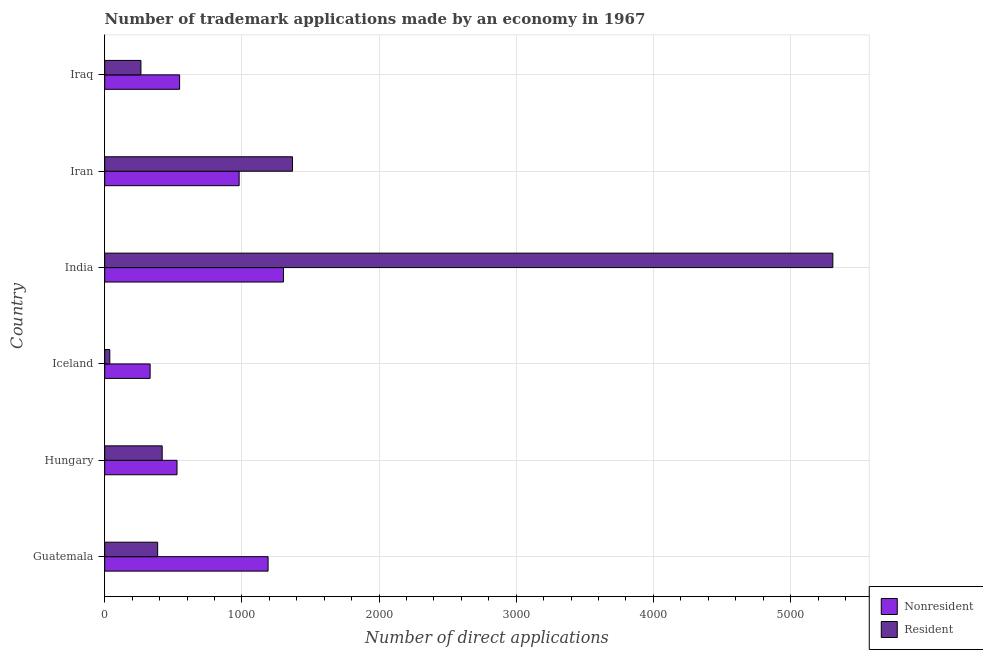How many different coloured bars are there?
Ensure brevity in your answer.  2. How many bars are there on the 3rd tick from the top?
Ensure brevity in your answer.  2. What is the label of the 6th group of bars from the top?
Offer a terse response. Guatemala. In how many cases, is the number of bars for a given country not equal to the number of legend labels?
Make the answer very short. 0. What is the number of trademark applications made by non residents in Iran?
Your answer should be very brief. 980. Across all countries, what is the maximum number of trademark applications made by non residents?
Ensure brevity in your answer.  1303. Across all countries, what is the minimum number of trademark applications made by non residents?
Make the answer very short. 331. In which country was the number of trademark applications made by residents maximum?
Provide a succinct answer. India. In which country was the number of trademark applications made by non residents minimum?
Give a very brief answer. Iceland. What is the total number of trademark applications made by residents in the graph?
Offer a terse response. 7783. What is the difference between the number of trademark applications made by non residents in Guatemala and that in Iraq?
Offer a very short reply. 645. What is the difference between the number of trademark applications made by residents in Guatemala and the number of trademark applications made by non residents in India?
Your answer should be compact. -917. What is the average number of trademark applications made by residents per country?
Provide a short and direct response. 1297.17. What is the difference between the number of trademark applications made by residents and number of trademark applications made by non residents in Hungary?
Provide a short and direct response. -108. In how many countries, is the number of trademark applications made by non residents greater than 1200 ?
Offer a terse response. 1. What is the ratio of the number of trademark applications made by non residents in Hungary to that in Iceland?
Keep it short and to the point. 1.59. Is the number of trademark applications made by non residents in Iceland less than that in Iran?
Provide a succinct answer. Yes. What is the difference between the highest and the second highest number of trademark applications made by non residents?
Offer a terse response. 112. What is the difference between the highest and the lowest number of trademark applications made by non residents?
Provide a succinct answer. 972. What does the 1st bar from the top in India represents?
Give a very brief answer. Resident. What does the 1st bar from the bottom in India represents?
Offer a very short reply. Nonresident. How many bars are there?
Provide a short and direct response. 12. What is the difference between two consecutive major ticks on the X-axis?
Your answer should be compact. 1000. Where does the legend appear in the graph?
Offer a terse response. Bottom right. What is the title of the graph?
Your response must be concise. Number of trademark applications made by an economy in 1967. What is the label or title of the X-axis?
Your answer should be compact. Number of direct applications. What is the label or title of the Y-axis?
Ensure brevity in your answer.  Country. What is the Number of direct applications in Nonresident in Guatemala?
Your answer should be very brief. 1191. What is the Number of direct applications of Resident in Guatemala?
Your answer should be compact. 386. What is the Number of direct applications of Nonresident in Hungary?
Give a very brief answer. 527. What is the Number of direct applications of Resident in Hungary?
Provide a short and direct response. 419. What is the Number of direct applications of Nonresident in Iceland?
Give a very brief answer. 331. What is the Number of direct applications in Resident in Iceland?
Ensure brevity in your answer.  37. What is the Number of direct applications of Nonresident in India?
Provide a succinct answer. 1303. What is the Number of direct applications in Resident in India?
Make the answer very short. 5308. What is the Number of direct applications of Nonresident in Iran?
Provide a short and direct response. 980. What is the Number of direct applications in Resident in Iran?
Give a very brief answer. 1369. What is the Number of direct applications of Nonresident in Iraq?
Offer a very short reply. 546. What is the Number of direct applications in Resident in Iraq?
Give a very brief answer. 264. Across all countries, what is the maximum Number of direct applications in Nonresident?
Give a very brief answer. 1303. Across all countries, what is the maximum Number of direct applications in Resident?
Provide a short and direct response. 5308. Across all countries, what is the minimum Number of direct applications in Nonresident?
Offer a very short reply. 331. What is the total Number of direct applications of Nonresident in the graph?
Give a very brief answer. 4878. What is the total Number of direct applications of Resident in the graph?
Your answer should be very brief. 7783. What is the difference between the Number of direct applications of Nonresident in Guatemala and that in Hungary?
Provide a short and direct response. 664. What is the difference between the Number of direct applications in Resident in Guatemala and that in Hungary?
Offer a very short reply. -33. What is the difference between the Number of direct applications of Nonresident in Guatemala and that in Iceland?
Keep it short and to the point. 860. What is the difference between the Number of direct applications in Resident in Guatemala and that in Iceland?
Give a very brief answer. 349. What is the difference between the Number of direct applications in Nonresident in Guatemala and that in India?
Offer a very short reply. -112. What is the difference between the Number of direct applications of Resident in Guatemala and that in India?
Ensure brevity in your answer.  -4922. What is the difference between the Number of direct applications of Nonresident in Guatemala and that in Iran?
Offer a very short reply. 211. What is the difference between the Number of direct applications in Resident in Guatemala and that in Iran?
Give a very brief answer. -983. What is the difference between the Number of direct applications in Nonresident in Guatemala and that in Iraq?
Keep it short and to the point. 645. What is the difference between the Number of direct applications in Resident in Guatemala and that in Iraq?
Your answer should be very brief. 122. What is the difference between the Number of direct applications in Nonresident in Hungary and that in Iceland?
Offer a terse response. 196. What is the difference between the Number of direct applications of Resident in Hungary and that in Iceland?
Offer a terse response. 382. What is the difference between the Number of direct applications in Nonresident in Hungary and that in India?
Provide a succinct answer. -776. What is the difference between the Number of direct applications in Resident in Hungary and that in India?
Provide a short and direct response. -4889. What is the difference between the Number of direct applications of Nonresident in Hungary and that in Iran?
Your answer should be very brief. -453. What is the difference between the Number of direct applications in Resident in Hungary and that in Iran?
Your answer should be very brief. -950. What is the difference between the Number of direct applications of Nonresident in Hungary and that in Iraq?
Offer a terse response. -19. What is the difference between the Number of direct applications of Resident in Hungary and that in Iraq?
Give a very brief answer. 155. What is the difference between the Number of direct applications in Nonresident in Iceland and that in India?
Ensure brevity in your answer.  -972. What is the difference between the Number of direct applications in Resident in Iceland and that in India?
Ensure brevity in your answer.  -5271. What is the difference between the Number of direct applications of Nonresident in Iceland and that in Iran?
Give a very brief answer. -649. What is the difference between the Number of direct applications in Resident in Iceland and that in Iran?
Your answer should be compact. -1332. What is the difference between the Number of direct applications in Nonresident in Iceland and that in Iraq?
Your response must be concise. -215. What is the difference between the Number of direct applications of Resident in Iceland and that in Iraq?
Your answer should be compact. -227. What is the difference between the Number of direct applications of Nonresident in India and that in Iran?
Provide a succinct answer. 323. What is the difference between the Number of direct applications of Resident in India and that in Iran?
Offer a terse response. 3939. What is the difference between the Number of direct applications of Nonresident in India and that in Iraq?
Make the answer very short. 757. What is the difference between the Number of direct applications of Resident in India and that in Iraq?
Offer a terse response. 5044. What is the difference between the Number of direct applications of Nonresident in Iran and that in Iraq?
Keep it short and to the point. 434. What is the difference between the Number of direct applications of Resident in Iran and that in Iraq?
Your answer should be very brief. 1105. What is the difference between the Number of direct applications in Nonresident in Guatemala and the Number of direct applications in Resident in Hungary?
Ensure brevity in your answer.  772. What is the difference between the Number of direct applications of Nonresident in Guatemala and the Number of direct applications of Resident in Iceland?
Your answer should be compact. 1154. What is the difference between the Number of direct applications of Nonresident in Guatemala and the Number of direct applications of Resident in India?
Keep it short and to the point. -4117. What is the difference between the Number of direct applications in Nonresident in Guatemala and the Number of direct applications in Resident in Iran?
Your response must be concise. -178. What is the difference between the Number of direct applications of Nonresident in Guatemala and the Number of direct applications of Resident in Iraq?
Offer a terse response. 927. What is the difference between the Number of direct applications of Nonresident in Hungary and the Number of direct applications of Resident in Iceland?
Your response must be concise. 490. What is the difference between the Number of direct applications in Nonresident in Hungary and the Number of direct applications in Resident in India?
Offer a terse response. -4781. What is the difference between the Number of direct applications of Nonresident in Hungary and the Number of direct applications of Resident in Iran?
Ensure brevity in your answer.  -842. What is the difference between the Number of direct applications in Nonresident in Hungary and the Number of direct applications in Resident in Iraq?
Offer a terse response. 263. What is the difference between the Number of direct applications in Nonresident in Iceland and the Number of direct applications in Resident in India?
Provide a short and direct response. -4977. What is the difference between the Number of direct applications of Nonresident in Iceland and the Number of direct applications of Resident in Iran?
Ensure brevity in your answer.  -1038. What is the difference between the Number of direct applications in Nonresident in Iceland and the Number of direct applications in Resident in Iraq?
Keep it short and to the point. 67. What is the difference between the Number of direct applications of Nonresident in India and the Number of direct applications of Resident in Iran?
Give a very brief answer. -66. What is the difference between the Number of direct applications in Nonresident in India and the Number of direct applications in Resident in Iraq?
Make the answer very short. 1039. What is the difference between the Number of direct applications in Nonresident in Iran and the Number of direct applications in Resident in Iraq?
Your answer should be very brief. 716. What is the average Number of direct applications in Nonresident per country?
Give a very brief answer. 813. What is the average Number of direct applications in Resident per country?
Your answer should be very brief. 1297.17. What is the difference between the Number of direct applications of Nonresident and Number of direct applications of Resident in Guatemala?
Your answer should be very brief. 805. What is the difference between the Number of direct applications in Nonresident and Number of direct applications in Resident in Hungary?
Offer a very short reply. 108. What is the difference between the Number of direct applications of Nonresident and Number of direct applications of Resident in Iceland?
Make the answer very short. 294. What is the difference between the Number of direct applications in Nonresident and Number of direct applications in Resident in India?
Your response must be concise. -4005. What is the difference between the Number of direct applications of Nonresident and Number of direct applications of Resident in Iran?
Keep it short and to the point. -389. What is the difference between the Number of direct applications of Nonresident and Number of direct applications of Resident in Iraq?
Make the answer very short. 282. What is the ratio of the Number of direct applications in Nonresident in Guatemala to that in Hungary?
Make the answer very short. 2.26. What is the ratio of the Number of direct applications in Resident in Guatemala to that in Hungary?
Ensure brevity in your answer.  0.92. What is the ratio of the Number of direct applications of Nonresident in Guatemala to that in Iceland?
Offer a terse response. 3.6. What is the ratio of the Number of direct applications in Resident in Guatemala to that in Iceland?
Provide a short and direct response. 10.43. What is the ratio of the Number of direct applications of Nonresident in Guatemala to that in India?
Ensure brevity in your answer.  0.91. What is the ratio of the Number of direct applications in Resident in Guatemala to that in India?
Offer a terse response. 0.07. What is the ratio of the Number of direct applications of Nonresident in Guatemala to that in Iran?
Offer a terse response. 1.22. What is the ratio of the Number of direct applications in Resident in Guatemala to that in Iran?
Offer a very short reply. 0.28. What is the ratio of the Number of direct applications of Nonresident in Guatemala to that in Iraq?
Your response must be concise. 2.18. What is the ratio of the Number of direct applications in Resident in Guatemala to that in Iraq?
Ensure brevity in your answer.  1.46. What is the ratio of the Number of direct applications in Nonresident in Hungary to that in Iceland?
Provide a succinct answer. 1.59. What is the ratio of the Number of direct applications in Resident in Hungary to that in Iceland?
Ensure brevity in your answer.  11.32. What is the ratio of the Number of direct applications of Nonresident in Hungary to that in India?
Make the answer very short. 0.4. What is the ratio of the Number of direct applications in Resident in Hungary to that in India?
Ensure brevity in your answer.  0.08. What is the ratio of the Number of direct applications in Nonresident in Hungary to that in Iran?
Make the answer very short. 0.54. What is the ratio of the Number of direct applications in Resident in Hungary to that in Iran?
Provide a short and direct response. 0.31. What is the ratio of the Number of direct applications of Nonresident in Hungary to that in Iraq?
Your answer should be very brief. 0.97. What is the ratio of the Number of direct applications of Resident in Hungary to that in Iraq?
Offer a very short reply. 1.59. What is the ratio of the Number of direct applications in Nonresident in Iceland to that in India?
Your response must be concise. 0.25. What is the ratio of the Number of direct applications of Resident in Iceland to that in India?
Make the answer very short. 0.01. What is the ratio of the Number of direct applications of Nonresident in Iceland to that in Iran?
Provide a succinct answer. 0.34. What is the ratio of the Number of direct applications in Resident in Iceland to that in Iran?
Offer a very short reply. 0.03. What is the ratio of the Number of direct applications in Nonresident in Iceland to that in Iraq?
Offer a terse response. 0.61. What is the ratio of the Number of direct applications of Resident in Iceland to that in Iraq?
Give a very brief answer. 0.14. What is the ratio of the Number of direct applications of Nonresident in India to that in Iran?
Give a very brief answer. 1.33. What is the ratio of the Number of direct applications of Resident in India to that in Iran?
Your response must be concise. 3.88. What is the ratio of the Number of direct applications of Nonresident in India to that in Iraq?
Your answer should be very brief. 2.39. What is the ratio of the Number of direct applications in Resident in India to that in Iraq?
Your response must be concise. 20.11. What is the ratio of the Number of direct applications of Nonresident in Iran to that in Iraq?
Your answer should be compact. 1.79. What is the ratio of the Number of direct applications in Resident in Iran to that in Iraq?
Offer a very short reply. 5.19. What is the difference between the highest and the second highest Number of direct applications of Nonresident?
Ensure brevity in your answer.  112. What is the difference between the highest and the second highest Number of direct applications in Resident?
Your response must be concise. 3939. What is the difference between the highest and the lowest Number of direct applications in Nonresident?
Ensure brevity in your answer.  972. What is the difference between the highest and the lowest Number of direct applications of Resident?
Offer a terse response. 5271. 